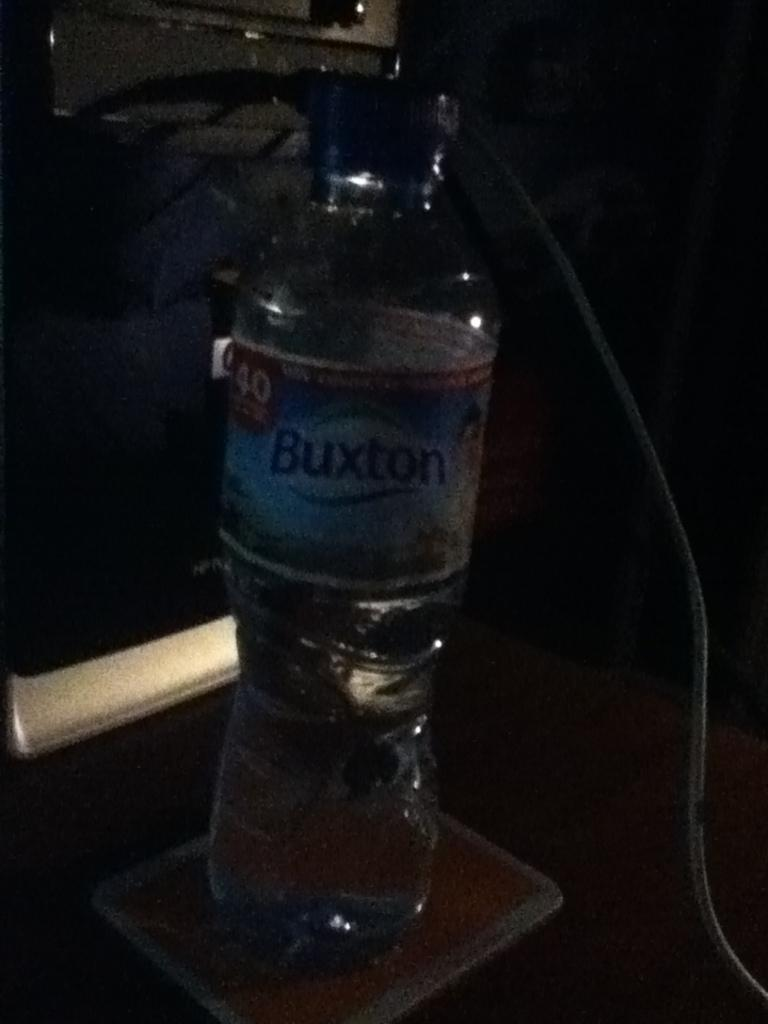Provide a one-sentence caption for the provided image. A bottle of Buxton water sits on a coaster. 